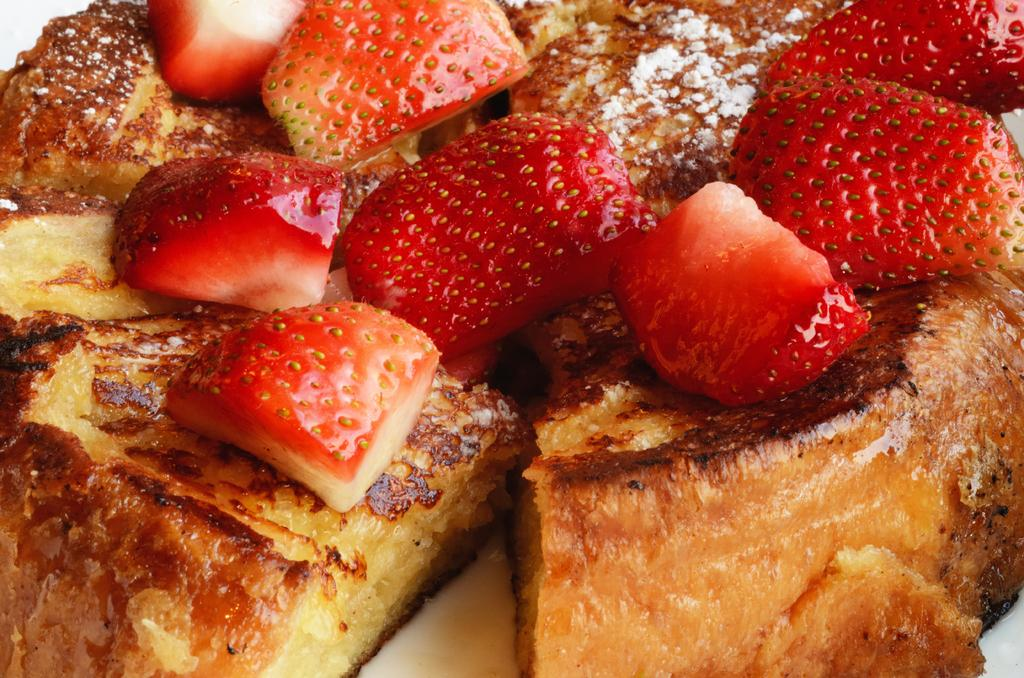What is present on the plate in the image? There are food items on a plate in the image. How many kittens are playing with the food on the plate in the image? There are no kittens present in the image; it only shows food items on a plate. Is there a sink visible in the image? There is no sink present in the image. 